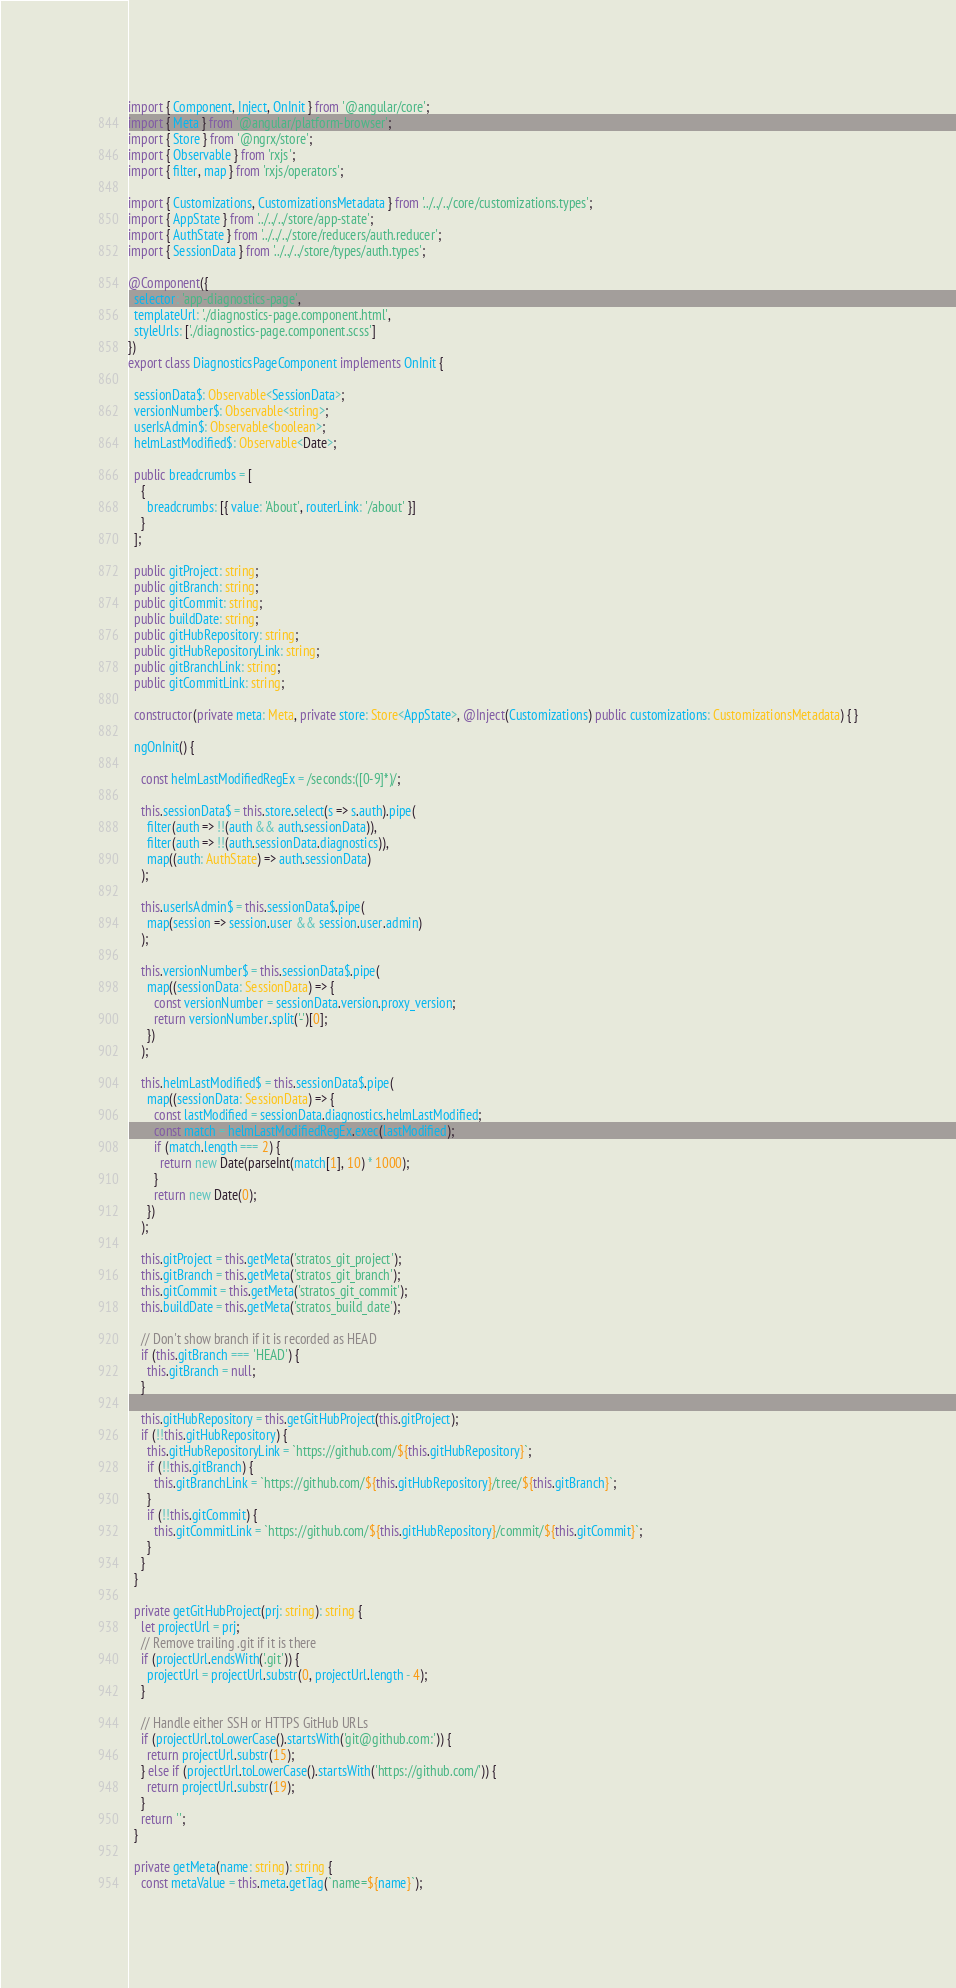<code> <loc_0><loc_0><loc_500><loc_500><_TypeScript_>import { Component, Inject, OnInit } from '@angular/core';
import { Meta } from '@angular/platform-browser';
import { Store } from '@ngrx/store';
import { Observable } from 'rxjs';
import { filter, map } from 'rxjs/operators';

import { Customizations, CustomizationsMetadata } from '../../../core/customizations.types';
import { AppState } from '../../../store/app-state';
import { AuthState } from '../../../store/reducers/auth.reducer';
import { SessionData } from '../../../store/types/auth.types';

@Component({
  selector: 'app-diagnostics-page',
  templateUrl: './diagnostics-page.component.html',
  styleUrls: ['./diagnostics-page.component.scss']
})
export class DiagnosticsPageComponent implements OnInit {

  sessionData$: Observable<SessionData>;
  versionNumber$: Observable<string>;
  userIsAdmin$: Observable<boolean>;
  helmLastModified$: Observable<Date>;

  public breadcrumbs = [
    {
      breadcrumbs: [{ value: 'About', routerLink: '/about' }]
    }
  ];

  public gitProject: string;
  public gitBranch: string;
  public gitCommit: string;
  public buildDate: string;
  public gitHubRepository: string;
  public gitHubRepositoryLink: string;
  public gitBranchLink: string;
  public gitCommitLink: string;

  constructor(private meta: Meta, private store: Store<AppState>, @Inject(Customizations) public customizations: CustomizationsMetadata) { }

  ngOnInit() {

    const helmLastModifiedRegEx = /seconds:([0-9]*)/;

    this.sessionData$ = this.store.select(s => s.auth).pipe(
      filter(auth => !!(auth && auth.sessionData)),
      filter(auth => !!(auth.sessionData.diagnostics)),
      map((auth: AuthState) => auth.sessionData)
    );

    this.userIsAdmin$ = this.sessionData$.pipe(
      map(session => session.user && session.user.admin)
    );

    this.versionNumber$ = this.sessionData$.pipe(
      map((sessionData: SessionData) => {
        const versionNumber = sessionData.version.proxy_version;
        return versionNumber.split('-')[0];
      })
    );

    this.helmLastModified$ = this.sessionData$.pipe(
      map((sessionData: SessionData) => {
        const lastModified = sessionData.diagnostics.helmLastModified;
        const match = helmLastModifiedRegEx.exec(lastModified);
        if (match.length === 2) {
          return new Date(parseInt(match[1], 10) * 1000);
        }
        return new Date(0);
      })
    );

    this.gitProject = this.getMeta('stratos_git_project');
    this.gitBranch = this.getMeta('stratos_git_branch');
    this.gitCommit = this.getMeta('stratos_git_commit');
    this.buildDate = this.getMeta('stratos_build_date');

    // Don't show branch if it is recorded as HEAD
    if (this.gitBranch === 'HEAD') {
      this.gitBranch = null;
    }

    this.gitHubRepository = this.getGitHubProject(this.gitProject);
    if (!!this.gitHubRepository) {
      this.gitHubRepositoryLink = `https://github.com/${this.gitHubRepository}`;
      if (!!this.gitBranch) {
        this.gitBranchLink = `https://github.com/${this.gitHubRepository}/tree/${this.gitBranch}`;
      }
      if (!!this.gitCommit) {
        this.gitCommitLink = `https://github.com/${this.gitHubRepository}/commit/${this.gitCommit}`;
      }
    }
  }

  private getGitHubProject(prj: string): string {
    let projectUrl = prj;
    // Remove trailing .git if it is there
    if (projectUrl.endsWith('.git')) {
      projectUrl = projectUrl.substr(0, projectUrl.length - 4);
    }

    // Handle either SSH or HTTPS GitHub URLs
    if (projectUrl.toLowerCase().startsWith('git@github.com:')) {
      return projectUrl.substr(15);
    } else if (projectUrl.toLowerCase().startsWith('https://github.com/')) {
      return projectUrl.substr(19);
    }
    return '';
  }

  private getMeta(name: string): string {
    const metaValue = this.meta.getTag(`name=${name}`);</code> 